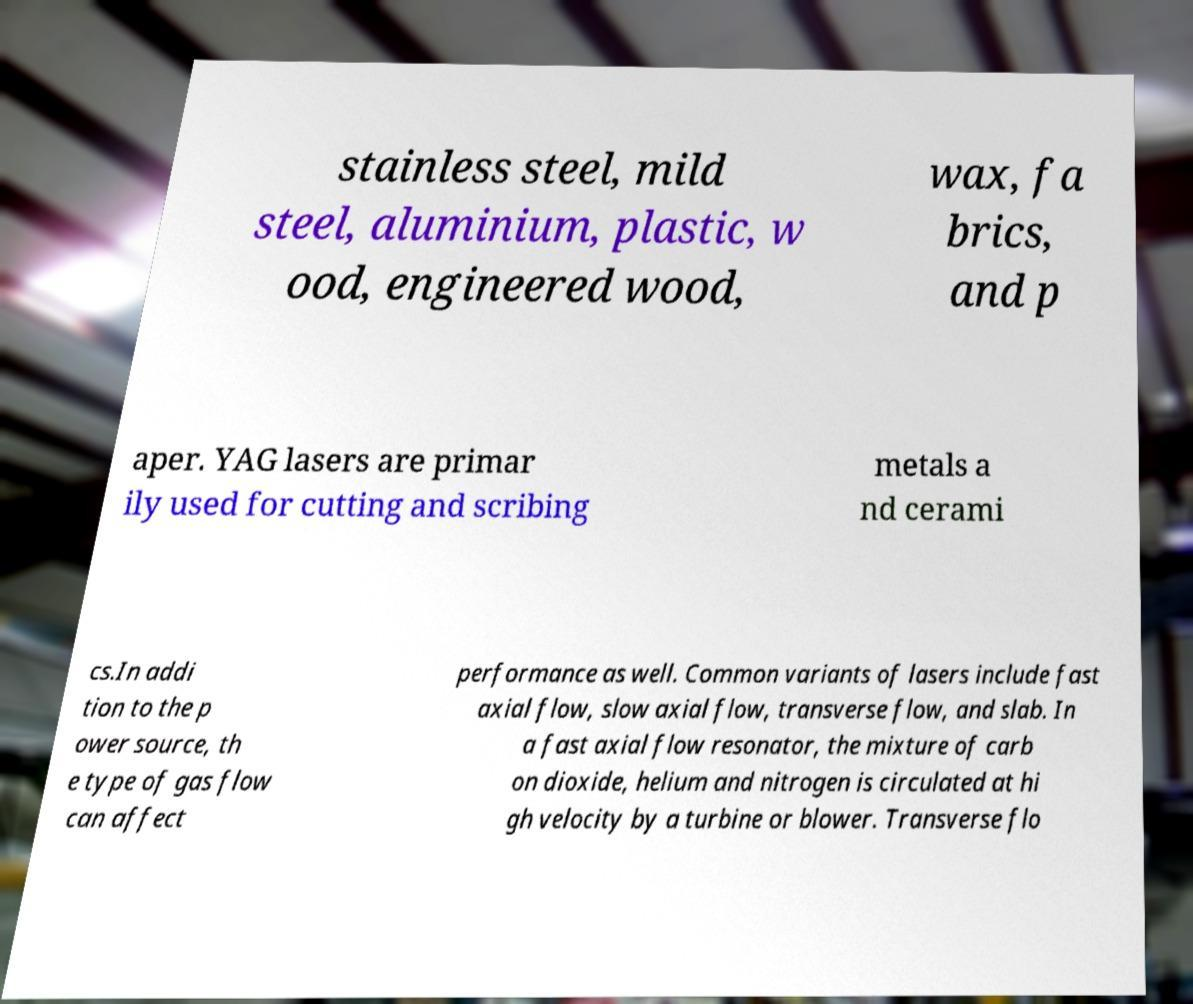Please identify and transcribe the text found in this image. stainless steel, mild steel, aluminium, plastic, w ood, engineered wood, wax, fa brics, and p aper. YAG lasers are primar ily used for cutting and scribing metals a nd cerami cs.In addi tion to the p ower source, th e type of gas flow can affect performance as well. Common variants of lasers include fast axial flow, slow axial flow, transverse flow, and slab. In a fast axial flow resonator, the mixture of carb on dioxide, helium and nitrogen is circulated at hi gh velocity by a turbine or blower. Transverse flo 